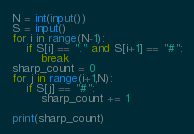Convert code to text. <code><loc_0><loc_0><loc_500><loc_500><_Python_>N = int(input())
S = input()
for i in range(N-1):
    if S[i] == "." and S[i+1] == "#":
        break
sharp_count = 0
for j in range(i+1,N):
    if S[j] == "#":
        sharp_count += 1

print(sharp_count)</code> 